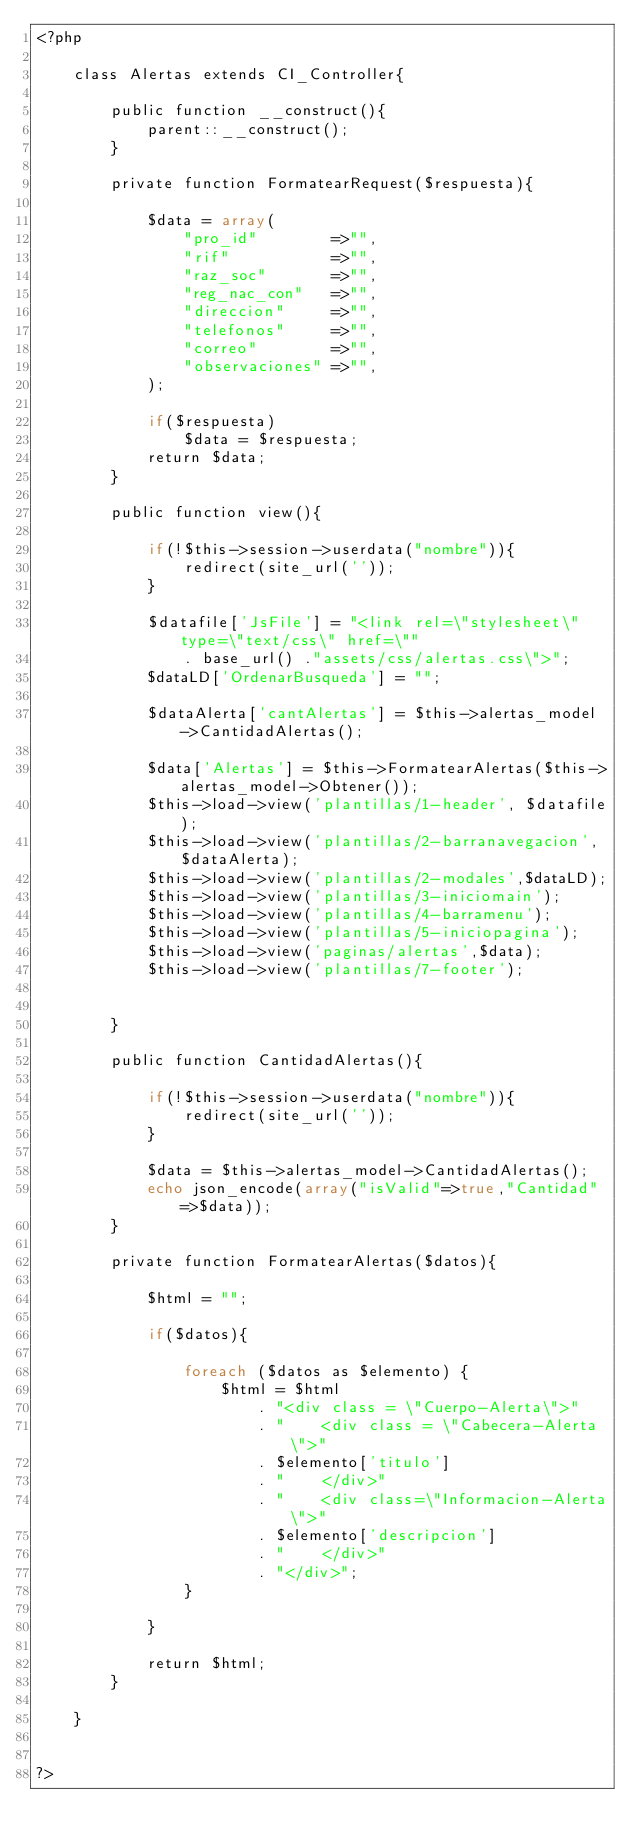Convert code to text. <code><loc_0><loc_0><loc_500><loc_500><_PHP_><?php

    class Alertas extends CI_Controller{

        public function __construct(){
            parent::__construct();
        }

        private function FormatearRequest($respuesta){

            $data = array(
                "pro_id"        =>"",
                "rif"           =>"",
                "raz_soc"       =>"",
                "reg_nac_con"   =>"",
                "direccion"     =>"",
                "telefonos"     =>"",
                "correo"        =>"",
                "observaciones" =>"",
            );

            if($respuesta)
                $data = $respuesta;
            return $data;
        }

        public function view(){
            
            if(!$this->session->userdata("nombre")){
                redirect(site_url(''));
            }
            
            $datafile['JsFile'] = "<link rel=\"stylesheet\" type=\"text/css\" href=\""
                . base_url() ."assets/css/alertas.css\">";
            $dataLD['OrdenarBusqueda'] = "";

            $dataAlerta['cantAlertas'] = $this->alertas_model->CantidadAlertas();

            $data['Alertas'] = $this->FormatearAlertas($this->alertas_model->Obtener());
            $this->load->view('plantillas/1-header', $datafile);
            $this->load->view('plantillas/2-barranavegacion',$dataAlerta);
            $this->load->view('plantillas/2-modales',$dataLD);
            $this->load->view('plantillas/3-iniciomain');
            $this->load->view('plantillas/4-barramenu');
            $this->load->view('plantillas/5-iniciopagina');
            $this->load->view('paginas/alertas',$data);
            $this->load->view('plantillas/7-footer');


        }

        public function CantidadAlertas(){

            if(!$this->session->userdata("nombre")){
                redirect(site_url(''));
            }

            $data = $this->alertas_model->CantidadAlertas();
            echo json_encode(array("isValid"=>true,"Cantidad"=>$data));
        }

        private function FormatearAlertas($datos){
            
            $html = "";

            if($datos){

                foreach ($datos as $elemento) {
                    $html = $html
                        . "<div class = \"Cuerpo-Alerta\">"
                        . "    <div class = \"Cabecera-Alerta\">"
                        . $elemento['titulo']
                        . "    </div>"
                        . "    <div class=\"Informacion-Alerta\">"
                        . $elemento['descripcion']
                        . "    </div>"
                        . "</div>";
                }
                
            }

            return $html;
        }

    }


?></code> 